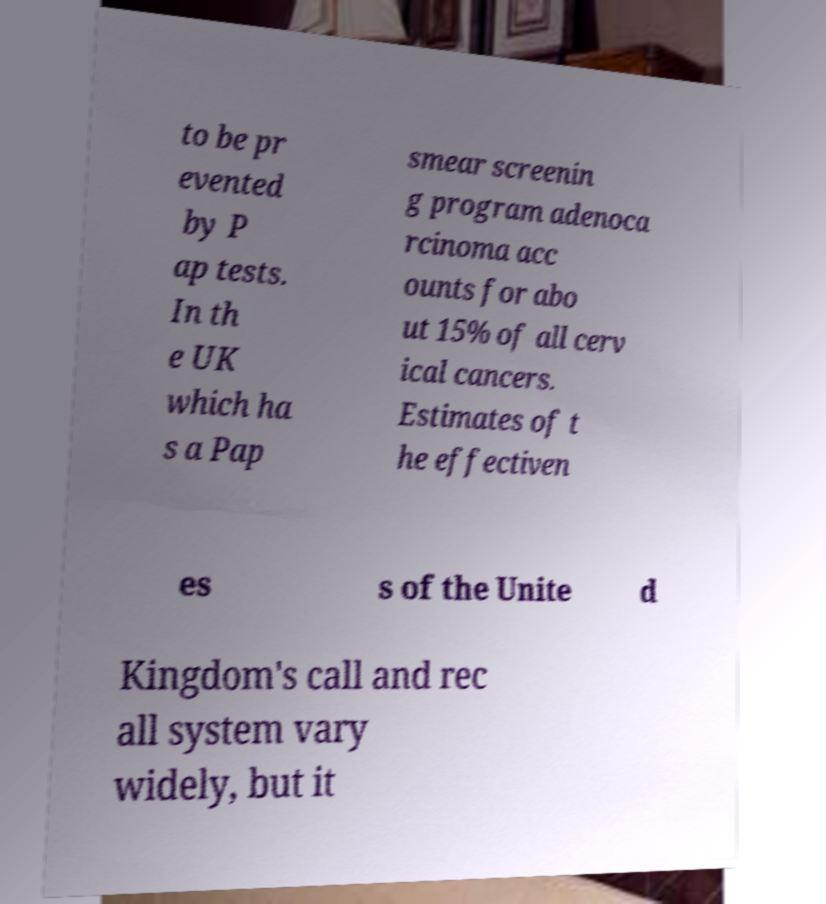I need the written content from this picture converted into text. Can you do that? to be pr evented by P ap tests. In th e UK which ha s a Pap smear screenin g program adenoca rcinoma acc ounts for abo ut 15% of all cerv ical cancers. Estimates of t he effectiven es s of the Unite d Kingdom's call and rec all system vary widely, but it 